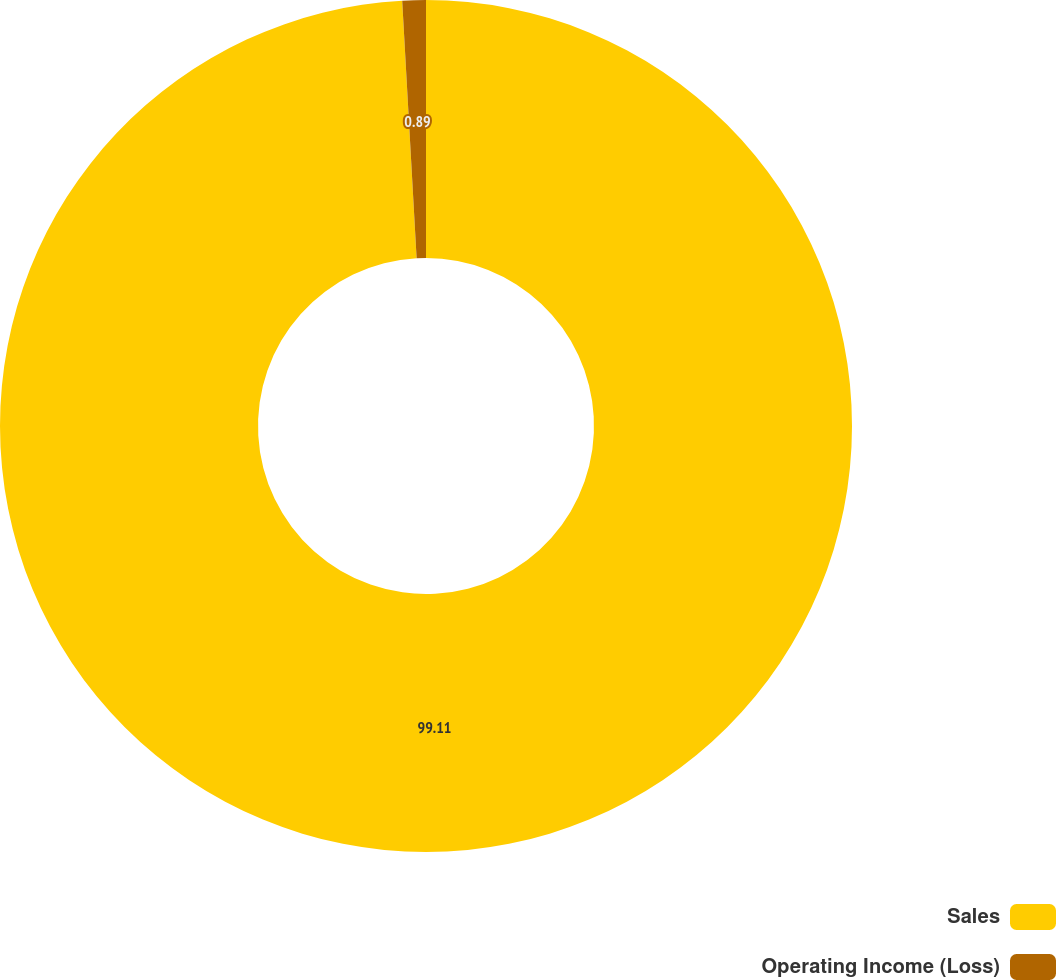Convert chart. <chart><loc_0><loc_0><loc_500><loc_500><pie_chart><fcel>Sales<fcel>Operating Income (Loss)<nl><fcel>99.11%<fcel>0.89%<nl></chart> 